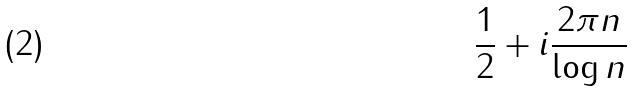Convert formula to latex. <formula><loc_0><loc_0><loc_500><loc_500>\frac { 1 } { 2 } + i \frac { 2 \pi n } { \log n }</formula> 